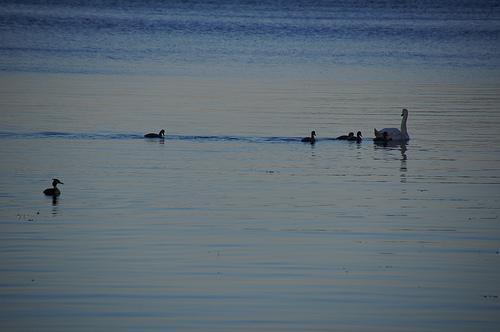How many animals are in the picture?
Give a very brief answer. 7. 